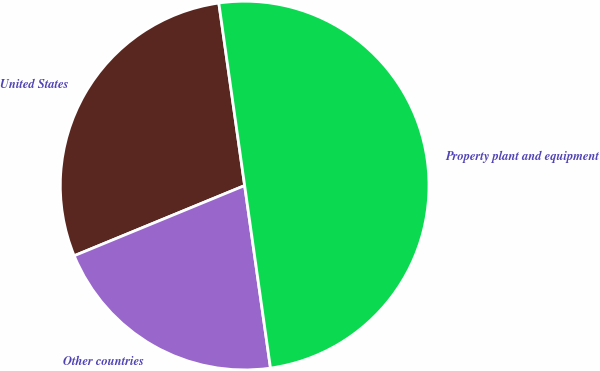Convert chart. <chart><loc_0><loc_0><loc_500><loc_500><pie_chart><fcel>United States<fcel>Other countries<fcel>Property plant and equipment<nl><fcel>28.98%<fcel>21.02%<fcel>50.0%<nl></chart> 